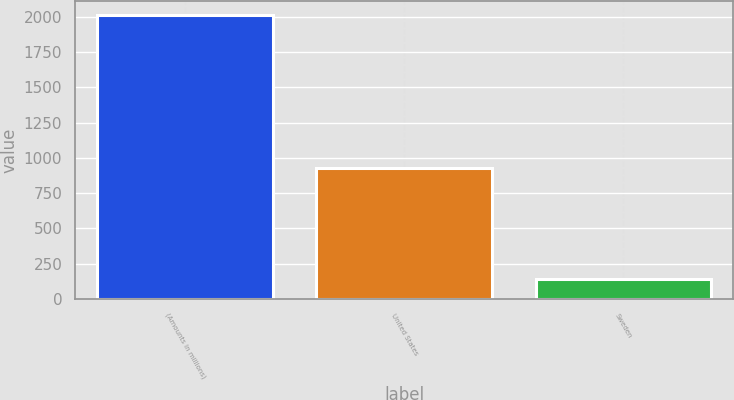Convert chart. <chart><loc_0><loc_0><loc_500><loc_500><bar_chart><fcel>(Amounts in millions)<fcel>United States<fcel>Sweden<nl><fcel>2011<fcel>929.4<fcel>137.5<nl></chart> 